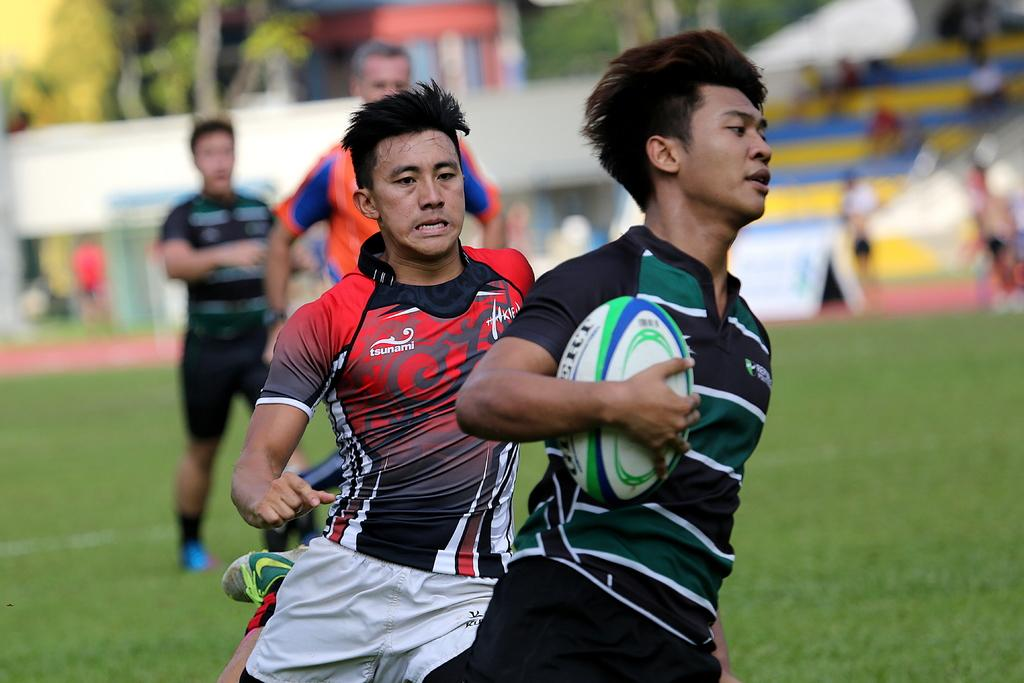What are the four persons in the image doing? The four persons in the image are running on the ground. Is there any object being held by one of the persons? Yes, one person is holding a ball in their hand. What can be seen in the background of the image? There are trees visible in the background, and there is a crowd of people in the background, but it is blurry. What type of van can be seen parked near the trees in the image? There is no van present in the image; only trees and a blurry crowd of people can be seen in the background. How many cats are visible in the image? There are no cats present in the image. 